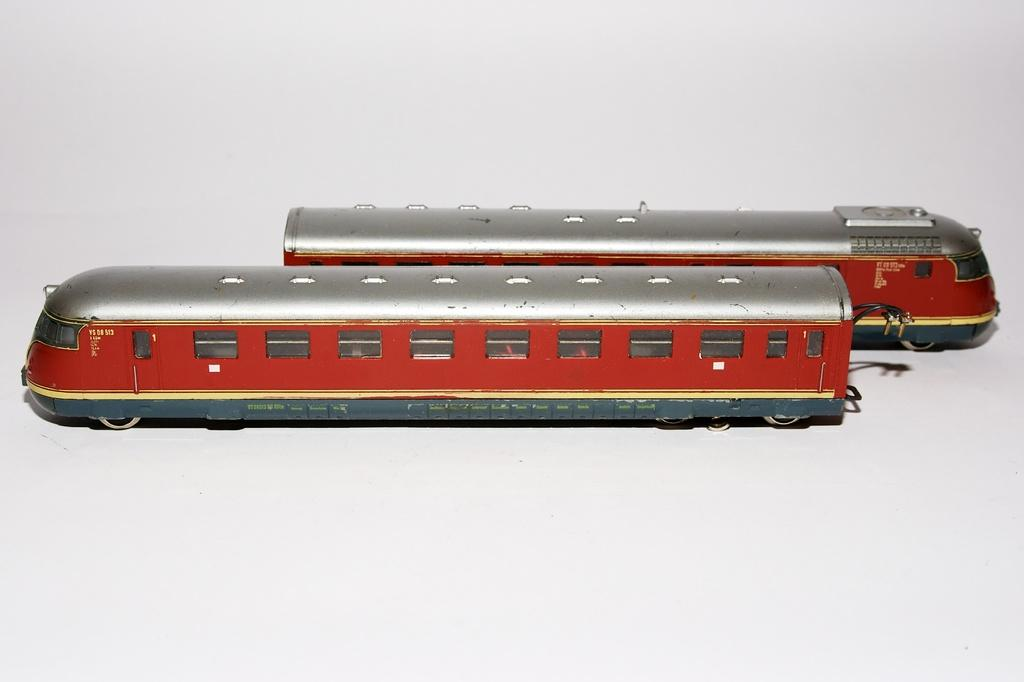What type of toy is present in the image? There are toy trains in the image. What is the color of the surface on which the toy trains are placed? The toy trains are on a white surface. Can you see any fog in the image? There is no fog present in the image. What type of books can be found in the library depicted in the image? There is no library present in the image, so it is not possible to determine what type of books might be found there. 